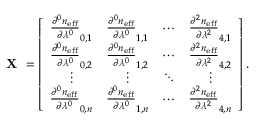Convert formula to latex. <formula><loc_0><loc_0><loc_500><loc_500>X = \left [ { \begin{array} { c c c c } { \frac { \partial ^ { 0 } n _ { e f f } } { \partial \lambda ^ { 0 } } _ { 0 , 1 } } & { \frac { \partial ^ { 0 } n _ { e f f } } { \partial \lambda ^ { 0 } } _ { 1 , 1 } } & { \cdots } & { \frac { \partial ^ { 2 } n _ { e f f } } { \partial \lambda ^ { 2 } } _ { 4 , 1 } } \\ { \frac { \partial ^ { 0 } n _ { e f f } } { \partial \lambda ^ { 0 } } _ { 0 , 2 } } & { \frac { \partial ^ { 0 } n _ { e f f } } { \partial \lambda ^ { 0 } } _ { 1 , 2 } } & { \cdots } & { \frac { \partial ^ { 2 } n _ { e f f } } { \partial \lambda ^ { 2 } } _ { 4 , 2 } } \\ { \vdots } & { \vdots } & { \ddots } & { \vdots } \\ { \frac { \partial ^ { 0 } n _ { e f f } } { \partial \lambda ^ { 0 } } _ { 0 , n } } & { \frac { \partial ^ { 0 } n _ { e f f } } { \partial \lambda ^ { 0 } } _ { 1 , n } } & { \cdots } & { \frac { \partial ^ { 2 } n _ { e f f } } { \partial \lambda ^ { 2 } } _ { 4 , n } } \end{array} } \right ] .</formula> 